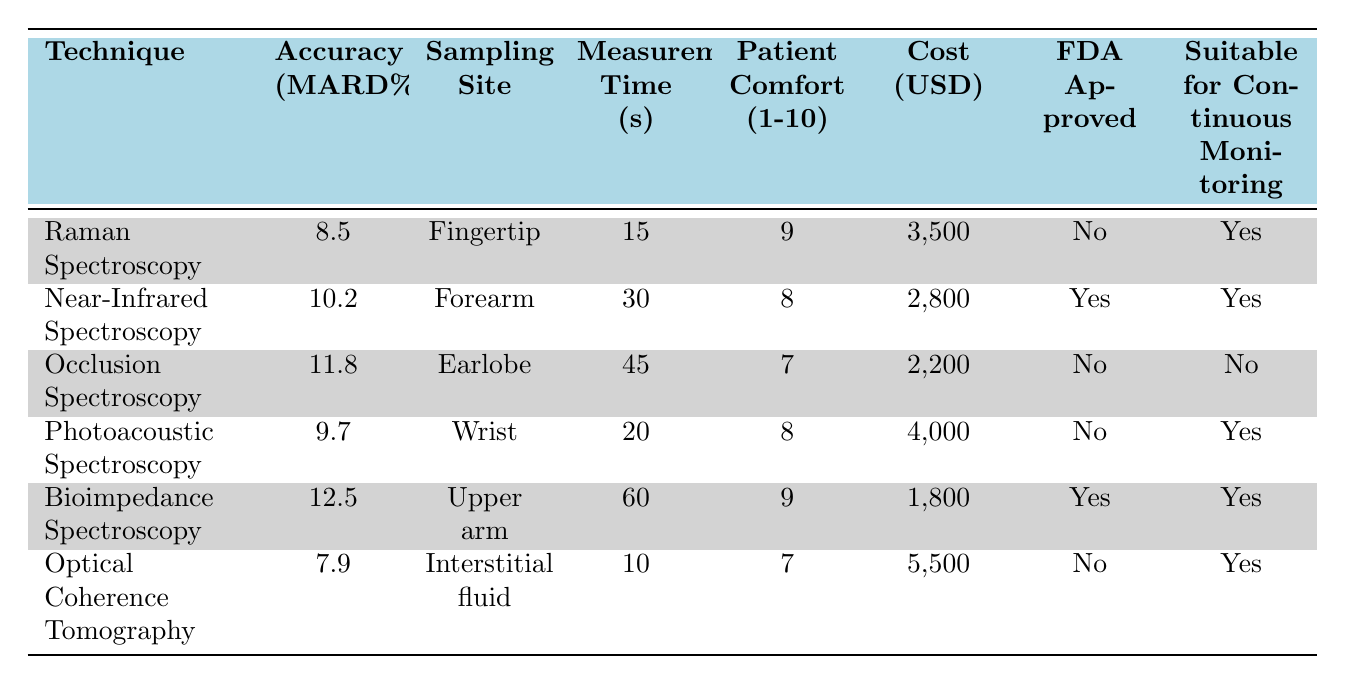What is the technique with the highest accuracy? To find the technique with the highest accuracy, we need to compare the Accuracy (MARD%) values across all techniques. By inspecting the table, we see that Bioimpedance Spectroscopy has the highest value at 12.5%.
Answer: Bioimpedance Spectroscopy Which technique has the lowest measurement time? The measurement time values for each technique are 15, 30, 45, 20, 60, and 10 seconds. The minimum value among these is 10 seconds, which corresponds to Optical Coherence Tomography.
Answer: Optical Coherence Tomography Is Near-Infrared Spectroscopy FDA approved? The FDA approval status for Near-Infrared Spectroscopy is listed in the table, and it indicates "Yes" in the corresponding row.
Answer: Yes How many techniques are suitable for continuous monitoring? By examining the table, we note which techniques are suitable for continuous monitoring: Raman Spectroscopy, Near-Infrared Spectroscopy, Photoacoustic Spectroscopy, Bioimpedance Spectroscopy, and Optical Coherence Tomography. This accounts for 5 techniques specifically.
Answer: 5 What is the average accuracy (MARD%) of all techniques? To find the average accuracy, we add the MARD% values: 8.5 + 10.2 + 11.8 + 9.7 + 12.5 + 7.9 = 60.6. Since there are 6 techniques, the average is 60.6 / 6 = 10.1%.
Answer: 10.1% Which technique has the highest patient comfort rating and what is that rating? Reviewing the Patient Comfort ratings, we find Raman Spectroscopy and Bioimpedance Spectroscopy both have a comfort rating of 9, which is the highest. However, since we want the one that appears first in the table, we take Raman Spectroscopy.
Answer: Raman Spectroscopy, 9 How much more does Optical Coherence Tomography cost compared to Bioimpedance Spectroscopy? The cost of Optical Coherence Tomography is 5500 USD, while Bioimpedance Spectroscopy is 1800 USD. The difference is 5500 - 1800 = 3700 USD.
Answer: 3700 Is it true that both Photoacoustic Spectroscopy and Occlusion Spectroscopy are not FDA approved? By checking the FDA Approval column, Photoacoustic Spectroscopy shows "No" and Occlusion Spectroscopy also shows "No". Hence, the statement is true.
Answer: True What is the patient comfort rating for the technique that is both FDA approved and has the longest measurement time? The only technique that is FDA approved and has the longest measurement time (60 seconds) is Bioimpedance Spectroscopy, which has a Patient Comfort rating of 9.
Answer: 9 